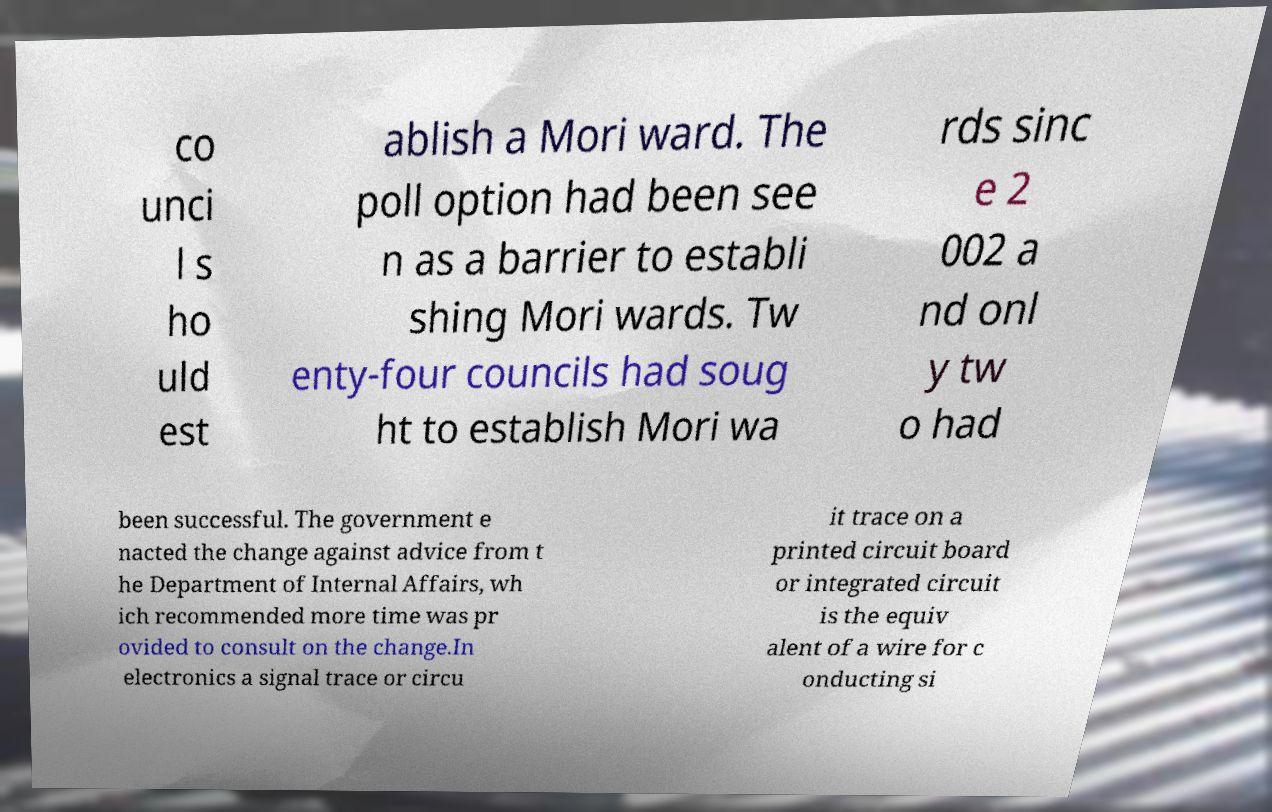What messages or text are displayed in this image? I need them in a readable, typed format. co unci l s ho uld est ablish a Mori ward. The poll option had been see n as a barrier to establi shing Mori wards. Tw enty-four councils had soug ht to establish Mori wa rds sinc e 2 002 a nd onl y tw o had been successful. The government e nacted the change against advice from t he Department of Internal Affairs, wh ich recommended more time was pr ovided to consult on the change.In electronics a signal trace or circu it trace on a printed circuit board or integrated circuit is the equiv alent of a wire for c onducting si 